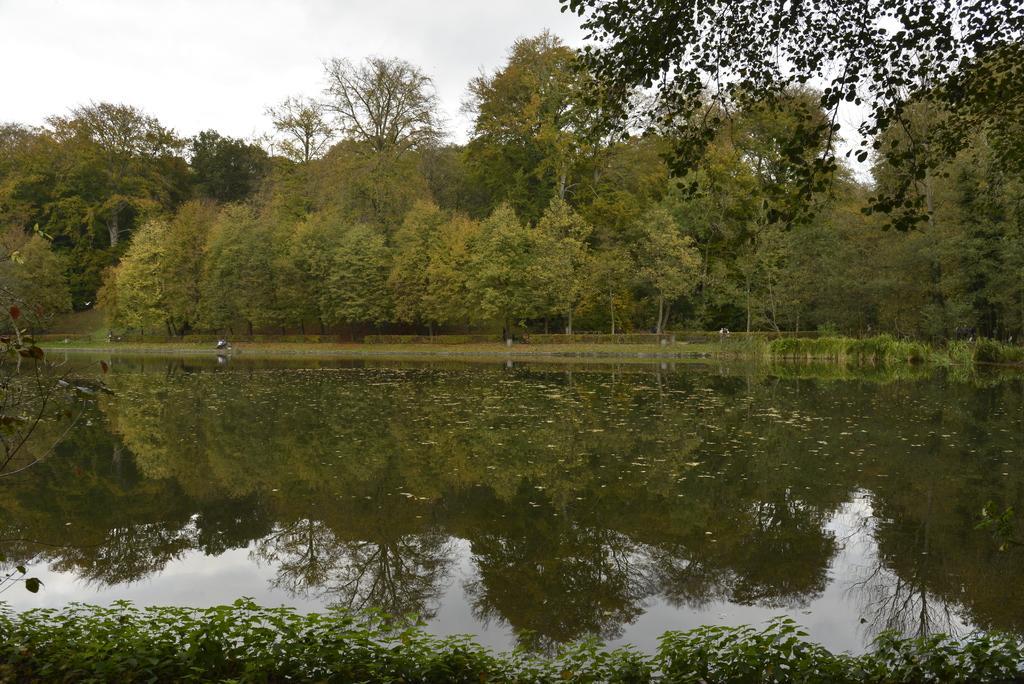In one or two sentences, can you explain what this image depicts? In this image there is the sky, there are trees, there are trees truncated towards the right of the image, there is a tree truncated towards the top of the image, there are trees truncated towards the left of the image, there is water truncated, there are plants truncated towards the bottom of the image. 